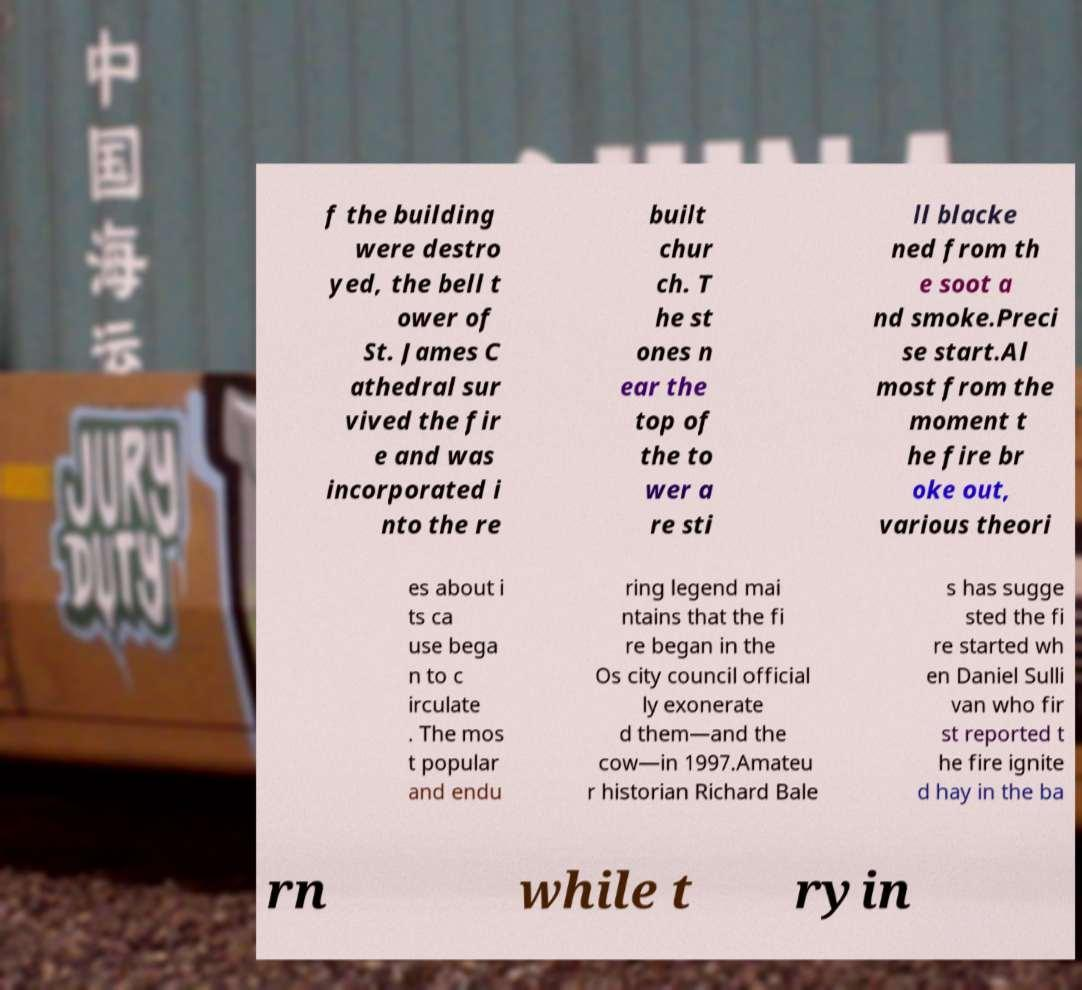Please identify and transcribe the text found in this image. f the building were destro yed, the bell t ower of St. James C athedral sur vived the fir e and was incorporated i nto the re built chur ch. T he st ones n ear the top of the to wer a re sti ll blacke ned from th e soot a nd smoke.Preci se start.Al most from the moment t he fire br oke out, various theori es about i ts ca use bega n to c irculate . The mos t popular and endu ring legend mai ntains that the fi re began in the Os city council official ly exonerate d them—and the cow—in 1997.Amateu r historian Richard Bale s has sugge sted the fi re started wh en Daniel Sulli van who fir st reported t he fire ignite d hay in the ba rn while t ryin 